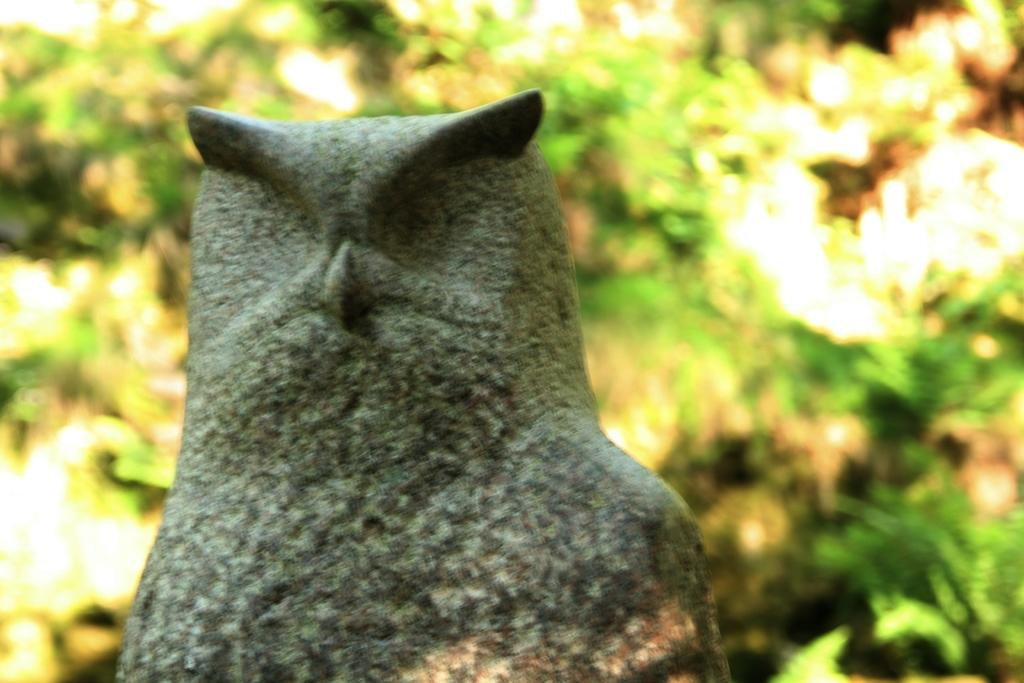What is the main subject of the image? There is a sculpture in the image. Can you describe the background of the image? The background of the image is blurred. How many horses are depicted in the sculpture? There is no mention of horses in the image or the provided facts. The image features a sculpture, but the details of the sculpture are not specified. 